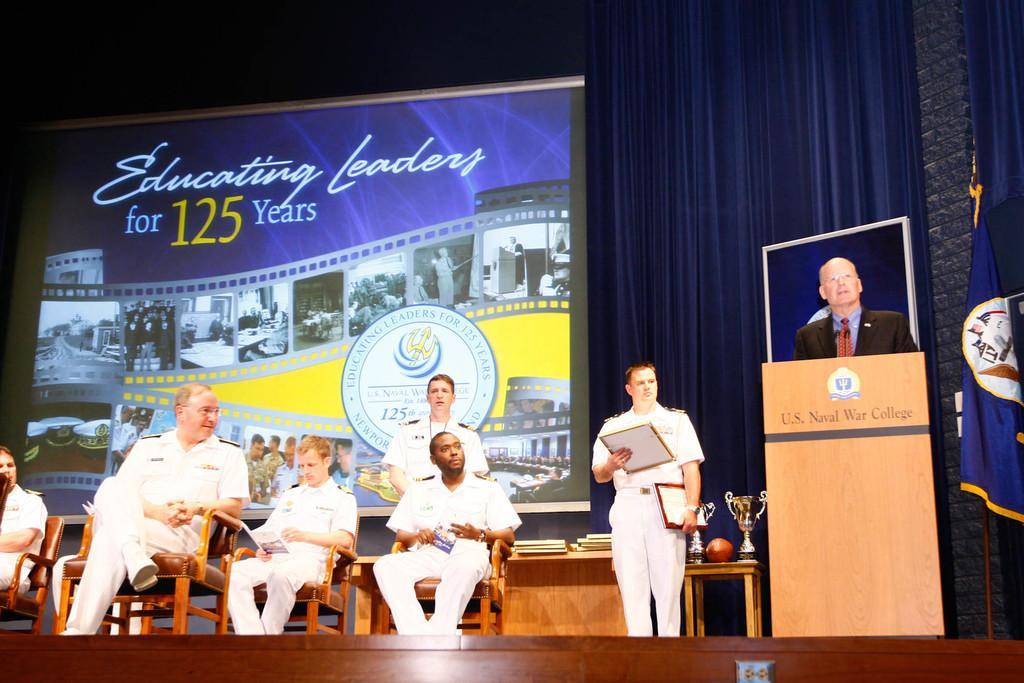How would you summarize this image in a sentence or two? In this image we can see some persons, chairs, podium and other objects. In the background of the image there is a banner, awards, books, tables, curtain, flag and other objects. At the bottom of the image there is a wooden texture. 